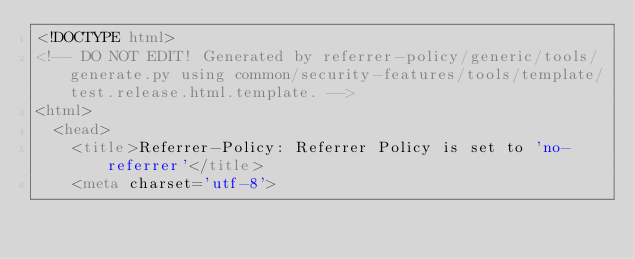<code> <loc_0><loc_0><loc_500><loc_500><_HTML_><!DOCTYPE html>
<!-- DO NOT EDIT! Generated by referrer-policy/generic/tools/generate.py using common/security-features/tools/template/test.release.html.template. -->
<html>
  <head>
    <title>Referrer-Policy: Referrer Policy is set to 'no-referrer'</title>
    <meta charset='utf-8'></code> 